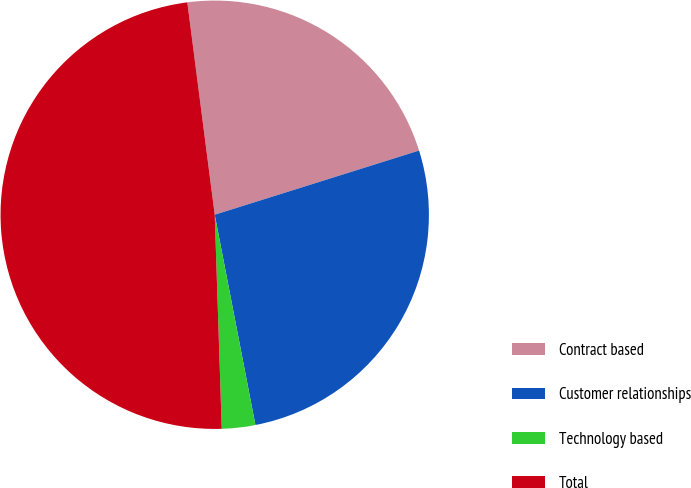Convert chart. <chart><loc_0><loc_0><loc_500><loc_500><pie_chart><fcel>Contract based<fcel>Customer relationships<fcel>Technology based<fcel>Total<nl><fcel>22.2%<fcel>26.8%<fcel>2.52%<fcel>48.48%<nl></chart> 